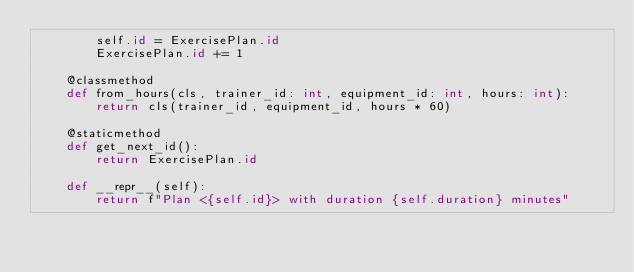Convert code to text. <code><loc_0><loc_0><loc_500><loc_500><_Python_>        self.id = ExercisePlan.id
        ExercisePlan.id += 1

    @classmethod
    def from_hours(cls, trainer_id: int, equipment_id: int, hours: int):
        return cls(trainer_id, equipment_id, hours * 60)

    @staticmethod
    def get_next_id():
        return ExercisePlan.id

    def __repr__(self):
        return f"Plan <{self.id}> with duration {self.duration} minutes"
</code> 